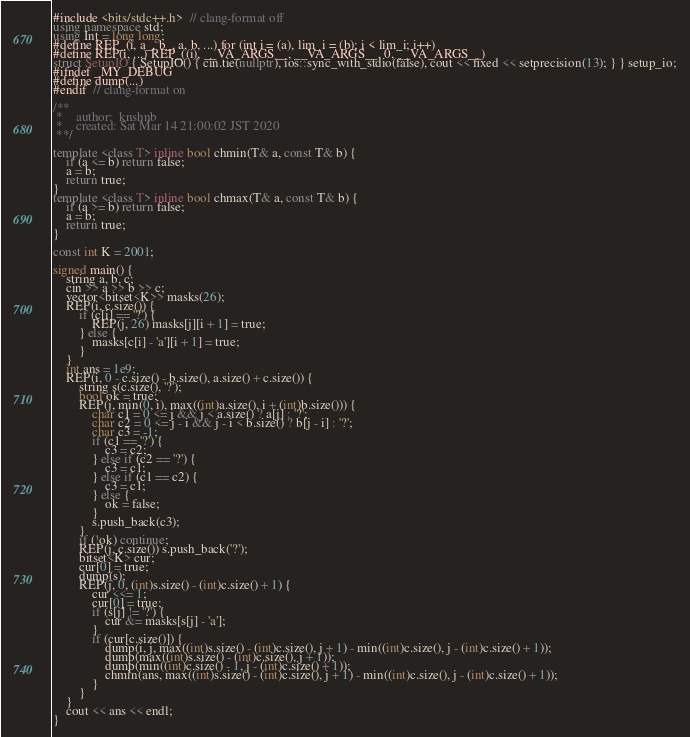<code> <loc_0><loc_0><loc_500><loc_500><_C++_>#include <bits/stdc++.h>  // clang-format off
using namespace std;
using Int = long long;
#define REP_(i, a_, b_, a, b, ...) for (int i = (a), lim_i = (b); i < lim_i; i++)
#define REP(i, ...) REP_((i), __VA_ARGS__, __VA_ARGS__, 0, __VA_ARGS__)
struct SetupIO { SetupIO() { cin.tie(nullptr), ios::sync_with_stdio(false), cout << fixed << setprecision(13); } } setup_io;
#ifndef _MY_DEBUG
#define dump(...)
#endif  // clang-format on

/**
 *    author:  knshnb
 *    created: Sat Mar 14 21:00:02 JST 2020
 **/

template <class T> inline bool chmin(T& a, const T& b) {
    if (a <= b) return false;
    a = b;
    return true;
}
template <class T> inline bool chmax(T& a, const T& b) {
    if (a >= b) return false;
    a = b;
    return true;
}

const int K = 2001;

signed main() {
    string a, b, c;
    cin >> a >> b >> c;
    vector<bitset<K>> masks(26);
    REP(i, c.size()) {
        if (c[i] == '?') {
            REP(j, 26) masks[j][i + 1] = true;
        } else {
            masks[c[i] - 'a'][i + 1] = true;
        }
    }
    int ans = 1e9;
    REP(i, 0 - c.size() - b.size(), a.size() + c.size()) {
        string s(c.size(), '?');
        bool ok = true;
        REP(j, min(0, i), max((int)a.size(), i + (int)b.size())) {
            char c1 = 0 <= j && j < a.size() ? a[j] : '?';
            char c2 = 0 <= j - i && j - i < b.size() ? b[j - i] : '?';
            char c3 = -1;
            if (c1 == '?') {
                c3 = c2;
            } else if (c2 == '?') {
                c3 = c1;
            } else if (c1 == c2) {
                c3 = c1;
            } else {
                ok = false;
            }
            s.push_back(c3);
        }
        if (!ok) continue;
        REP(j, c.size()) s.push_back('?');
        bitset<K> cur;
        cur[0] = true;
        dump(s);
        REP(j, 0, (int)s.size() - (int)c.size() + 1) {
            cur <<= 1;
            cur[0] = true;
            if (s[j] != '?') {
                cur &= masks[s[j] - 'a'];
            }
            if (cur[c.size()]) {
                dump(i, j, max((int)s.size() - (int)c.size(), j + 1) - min((int)c.size(), j - (int)c.size() + 1));
                dump(max((int)s.size() - (int)c.size(), j + 1));
                dump(min((int)c.size() - 1, j - (int)c.size() + 1));
                chmin(ans, max((int)s.size() - (int)c.size(), j + 1) - min((int)c.size(), j - (int)c.size() + 1));
            }
        }
    }
    cout << ans << endl;
}
</code> 